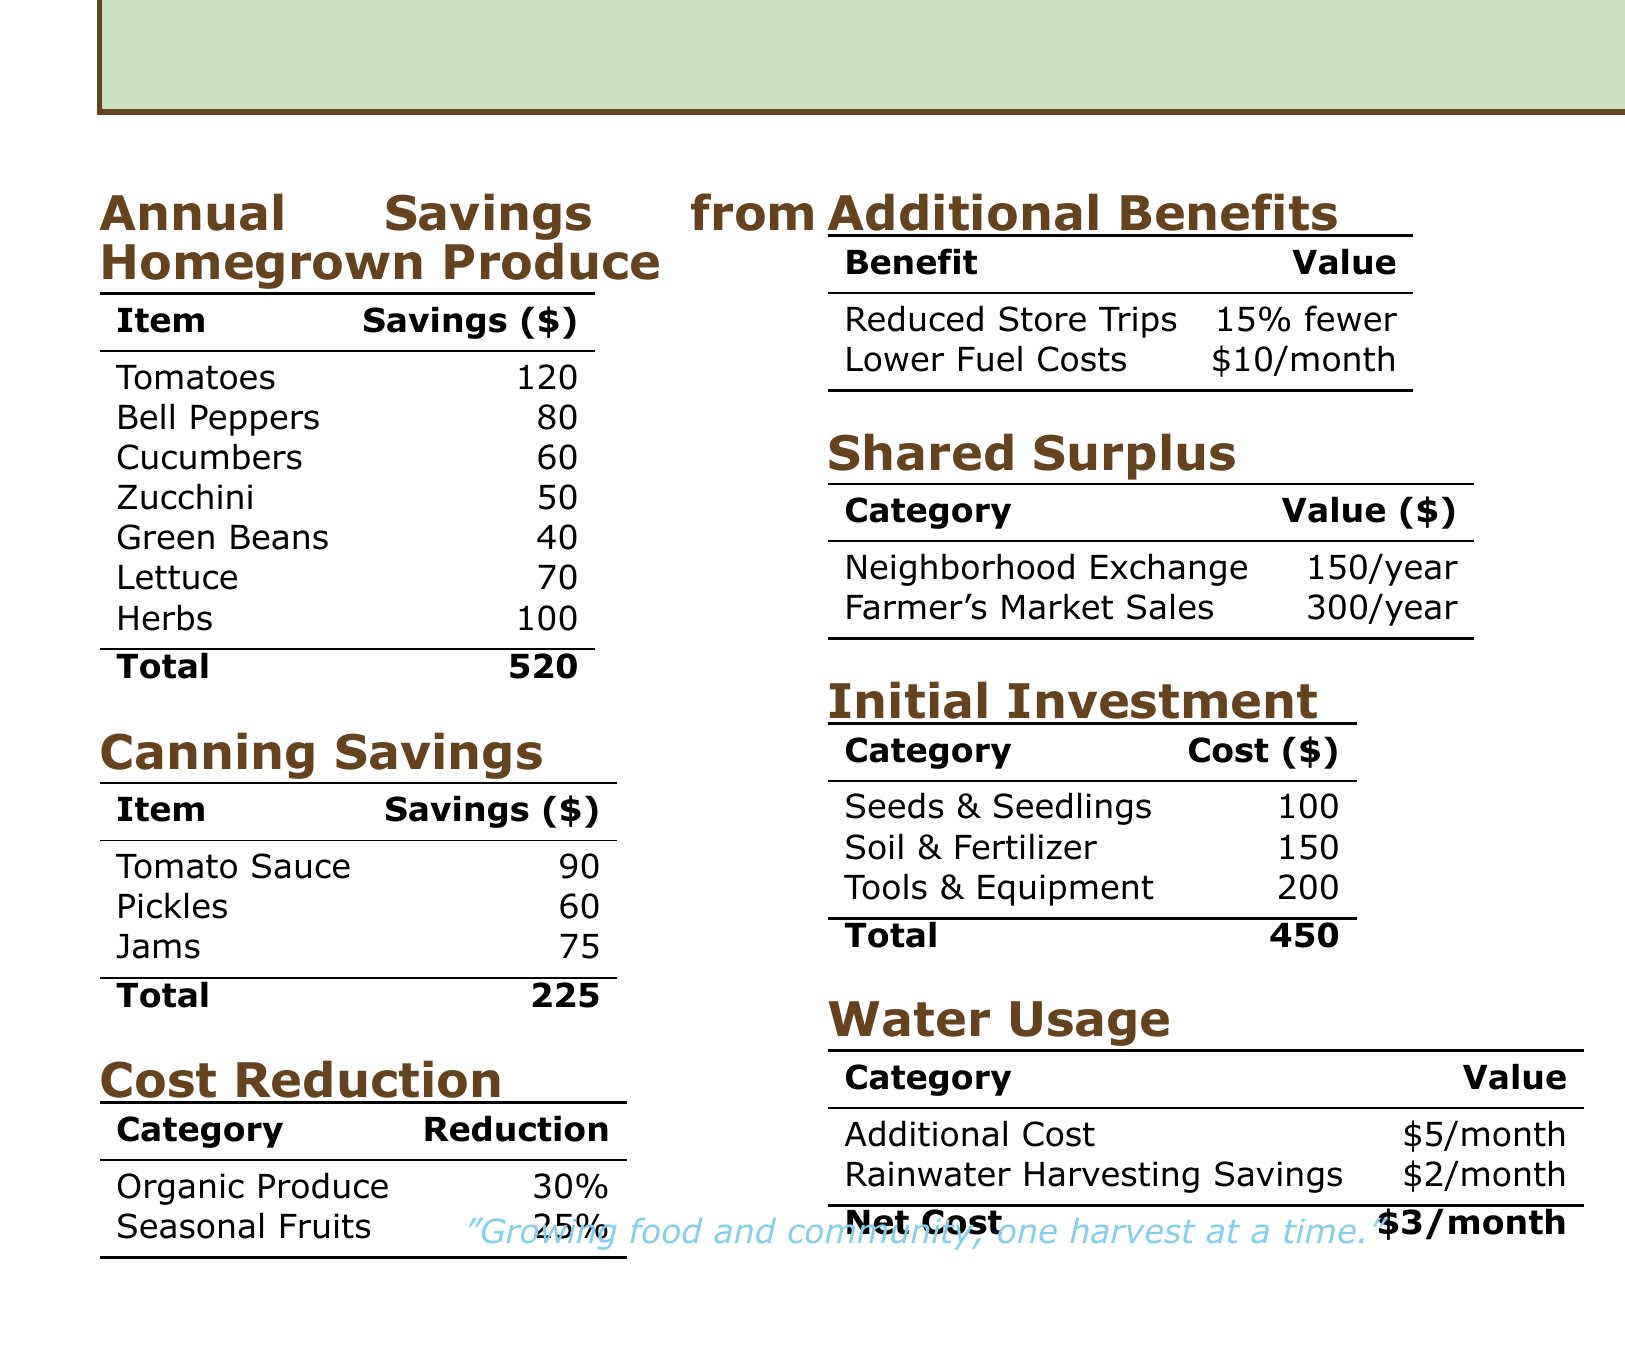What is the total estimated savings from homegrown produce? The total estimated savings is the sum of savings from all produce categories listed in the document.
Answer: 520 How much canning savings are there from jams? The canning savings specifically from jams is listed in the document.
Answer: 75 What is the organic produce cost reduction percentage? The document states that organic produce costs have a reduction percentage that is explicitly mentioned.
Answer: 30% How much do neighborhood exchanges yield annually? The document specifies the annual value generated from neighborhood exchanges.
Answer: 150/year What is the initial investment total? The initial investment total is calculated by adding all the costs of seeds, soil, and tools listed.
Answer: 450 How much are the lower fuel costs per month? The ongoing lower fuel costs due to homegrown produce are mentioned in the document.
Answer: 10/month What is the tomato savings? The savings specifically attributed to tomatoes is clearly stated in the document.
Answer: 120 What is the total canning savings? The total canning savings is obtained by adding all the savings from canning items in the document.
Answer: 225 What is the net water usage cost per month? The document provides a net cost associated with water usage, which is derived from the additional cost and harvesting savings.
Answer: 3/month 